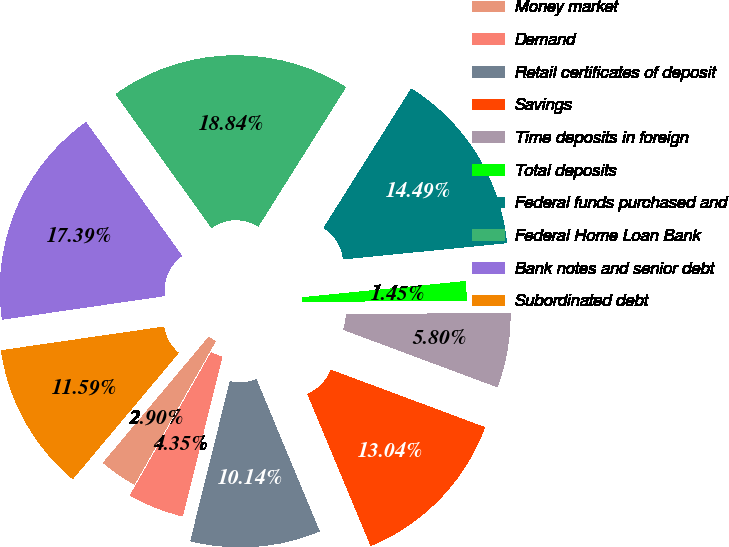Convert chart to OTSL. <chart><loc_0><loc_0><loc_500><loc_500><pie_chart><fcel>Money market<fcel>Demand<fcel>Retail certificates of deposit<fcel>Savings<fcel>Time deposits in foreign<fcel>Total deposits<fcel>Federal funds purchased and<fcel>Federal Home Loan Bank<fcel>Bank notes and senior debt<fcel>Subordinated debt<nl><fcel>2.9%<fcel>4.35%<fcel>10.14%<fcel>13.04%<fcel>5.8%<fcel>1.45%<fcel>14.49%<fcel>18.84%<fcel>17.39%<fcel>11.59%<nl></chart> 